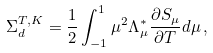<formula> <loc_0><loc_0><loc_500><loc_500>\Sigma _ { d } ^ { T , K } = \frac { 1 } { 2 } \int _ { - 1 } ^ { 1 } \mu ^ { 2 } \Lambda _ { \mu } ^ { \ast } \frac { \partial S _ { \mu } } { \partial T } d \mu \, ,</formula> 